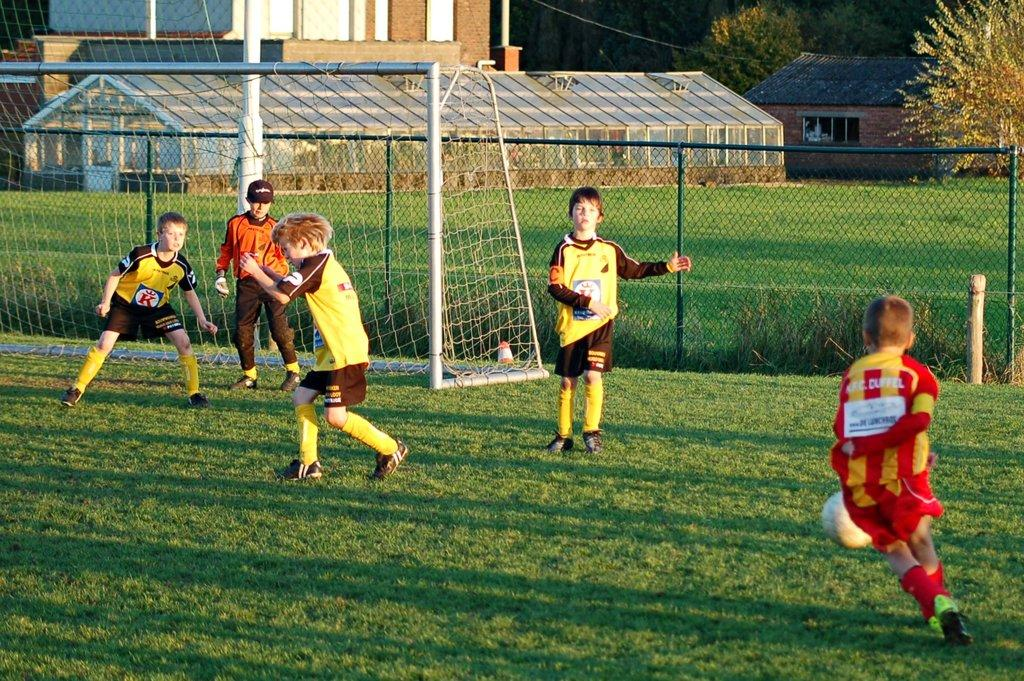<image>
Provide a brief description of the given image. a soccer player dribbling the ball with the Duffel on the back of his jersey 